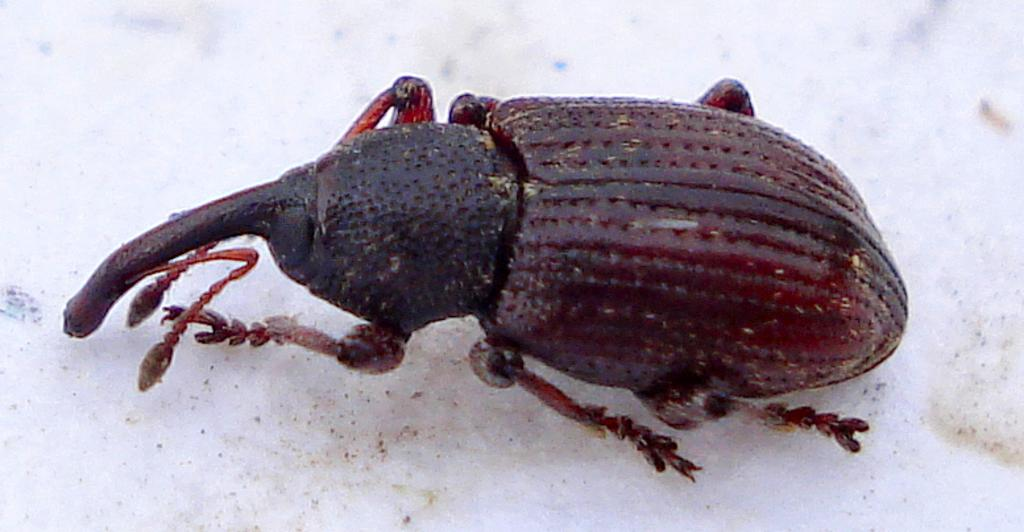What type of creature can be seen in the image? There is an insect in the image. What is the background or surface on which the insect is located? The insect is on a white surface. What type of book is the insect reading in the image? There is no book present in the image, and the insect is not reading anything. 